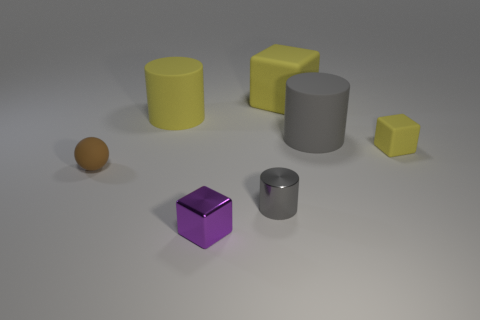Is there any other thing that is the same shape as the small brown object?
Offer a terse response. No. There is a purple object; does it have the same shape as the small matte thing right of the tiny gray cylinder?
Offer a very short reply. Yes. What number of metallic things are purple things or large cylinders?
Ensure brevity in your answer.  1. Is there another cylinder of the same color as the small metallic cylinder?
Your answer should be very brief. Yes. Are any purple rubber cubes visible?
Offer a very short reply. No. Is the shape of the big gray object the same as the gray metal object?
Make the answer very short. Yes. How many big objects are either brown matte objects or yellow things?
Keep it short and to the point. 2. The shiny cube has what color?
Offer a very short reply. Purple. The big yellow rubber object behind the large matte cylinder to the left of the large gray matte cylinder is what shape?
Your answer should be compact. Cube. Is there a blue sphere made of the same material as the yellow cylinder?
Provide a short and direct response. No. 